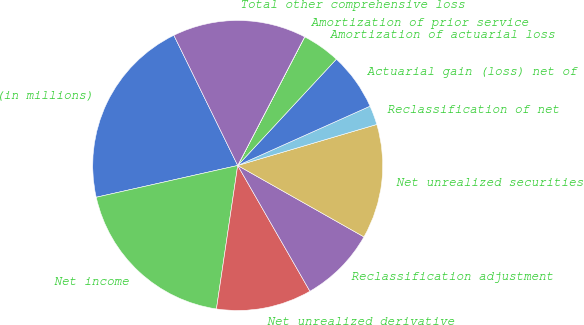<chart> <loc_0><loc_0><loc_500><loc_500><pie_chart><fcel>(in millions)<fcel>Net income<fcel>Net unrealized derivative<fcel>Reclassification adjustment<fcel>Net unrealized securities<fcel>Reclassification of net<fcel>Actuarial gain (loss) net of<fcel>Amortization of actuarial loss<fcel>Amortization of prior service<fcel>Total other comprehensive loss<nl><fcel>21.26%<fcel>19.14%<fcel>10.64%<fcel>8.51%<fcel>12.76%<fcel>2.14%<fcel>6.39%<fcel>4.26%<fcel>0.01%<fcel>14.89%<nl></chart> 